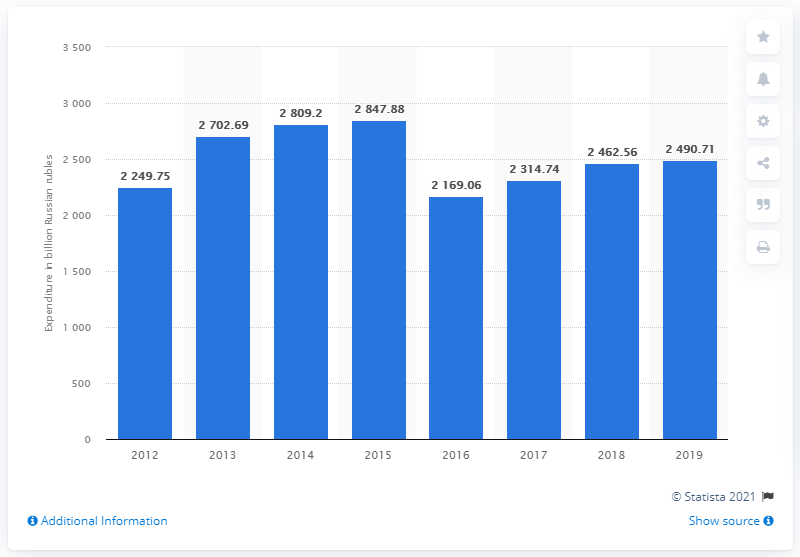Give some essential details in this illustration. In 2019, a total of 2490.71 Russian rubles was spent on outbound travel. 